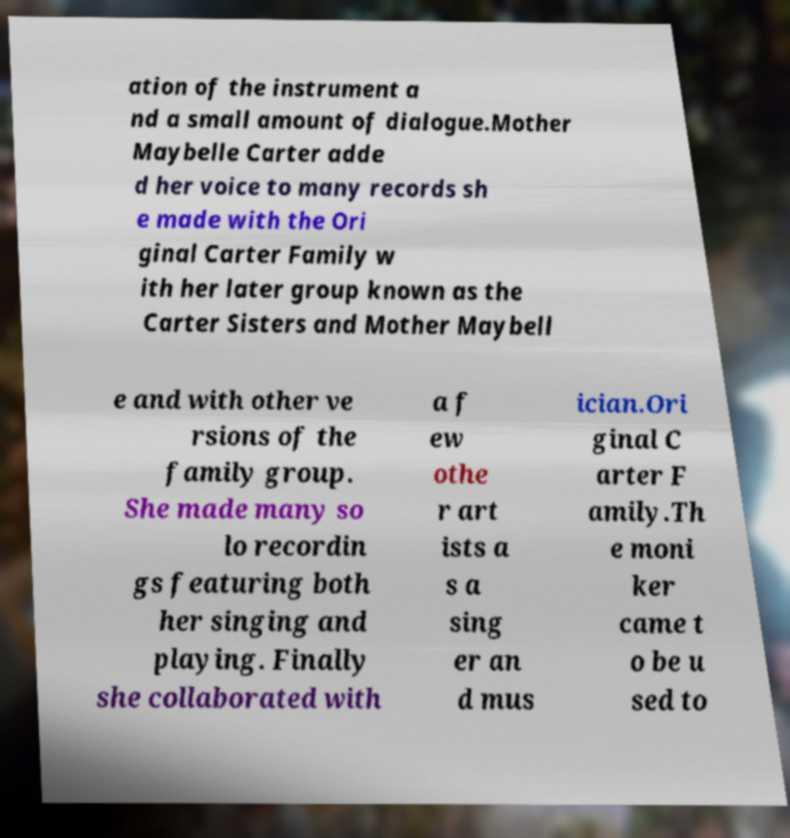Could you extract and type out the text from this image? ation of the instrument a nd a small amount of dialogue.Mother Maybelle Carter adde d her voice to many records sh e made with the Ori ginal Carter Family w ith her later group known as the Carter Sisters and Mother Maybell e and with other ve rsions of the family group. She made many so lo recordin gs featuring both her singing and playing. Finally she collaborated with a f ew othe r art ists a s a sing er an d mus ician.Ori ginal C arter F amily.Th e moni ker came t o be u sed to 